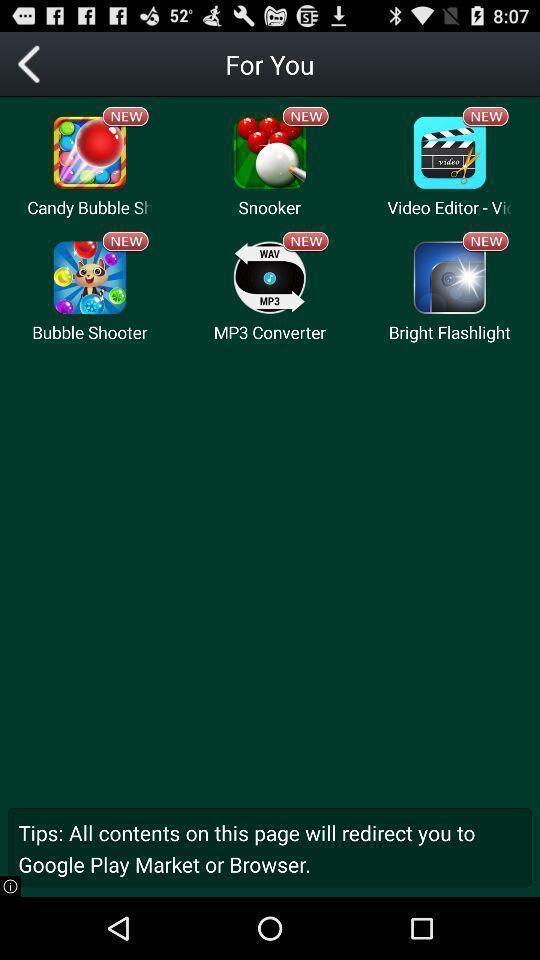What can you discern from this picture? Screen showing list of various applications in video player app. 